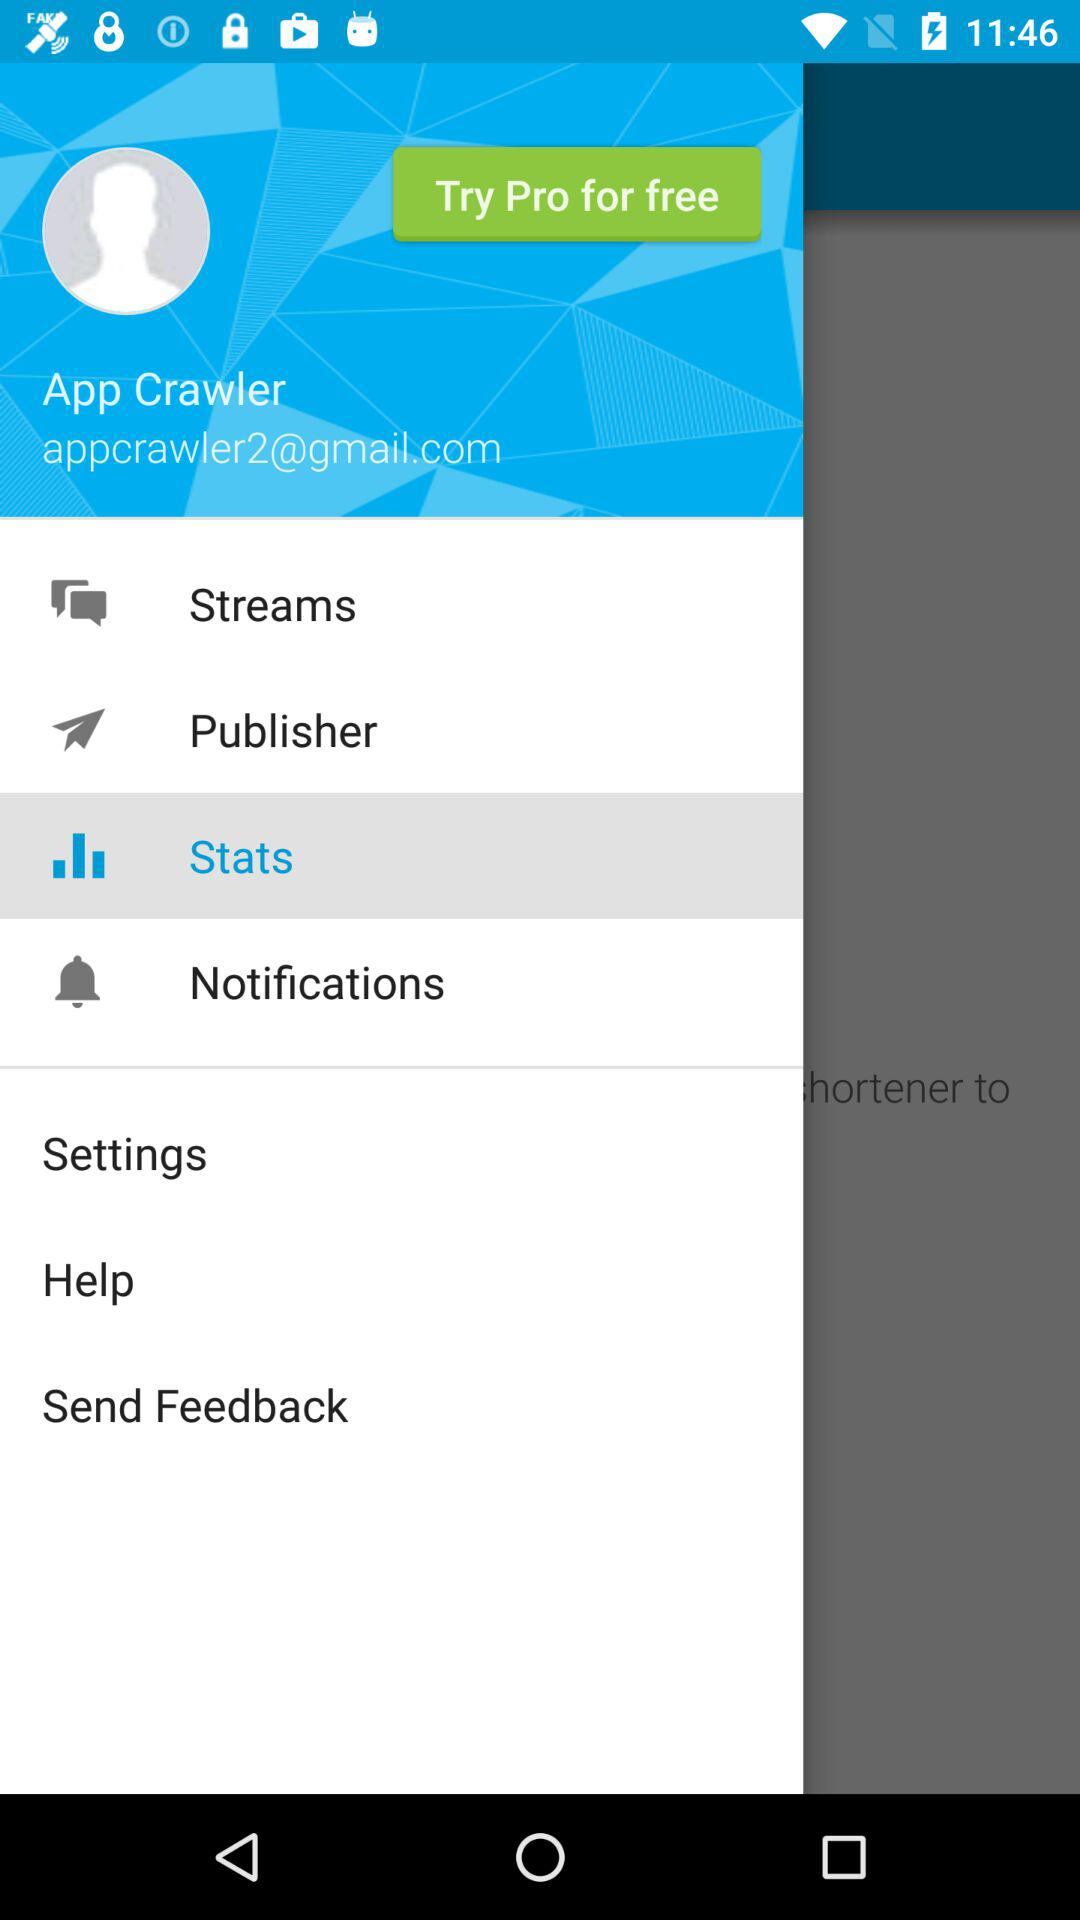Which option is selected? The selected option is "Stats". 